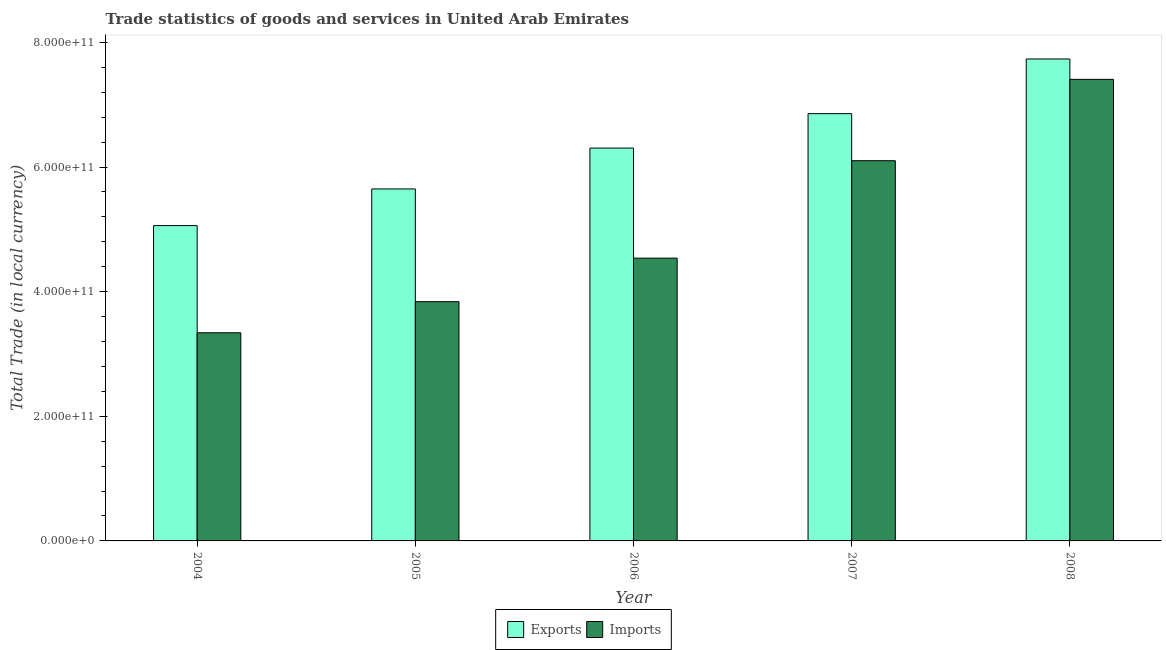How many groups of bars are there?
Your response must be concise. 5. Are the number of bars on each tick of the X-axis equal?
Your answer should be very brief. Yes. How many bars are there on the 3rd tick from the left?
Provide a succinct answer. 2. What is the export of goods and services in 2005?
Ensure brevity in your answer.  5.65e+11. Across all years, what is the maximum imports of goods and services?
Make the answer very short. 7.41e+11. Across all years, what is the minimum imports of goods and services?
Offer a very short reply. 3.34e+11. In which year was the imports of goods and services minimum?
Ensure brevity in your answer.  2004. What is the total export of goods and services in the graph?
Your answer should be very brief. 3.16e+12. What is the difference between the export of goods and services in 2004 and that in 2007?
Offer a very short reply. -1.80e+11. What is the difference between the imports of goods and services in 2008 and the export of goods and services in 2004?
Your response must be concise. 4.07e+11. What is the average export of goods and services per year?
Provide a succinct answer. 6.32e+11. In the year 2008, what is the difference between the imports of goods and services and export of goods and services?
Your response must be concise. 0. What is the ratio of the imports of goods and services in 2004 to that in 2008?
Your answer should be very brief. 0.45. Is the difference between the imports of goods and services in 2004 and 2008 greater than the difference between the export of goods and services in 2004 and 2008?
Your answer should be compact. No. What is the difference between the highest and the second highest imports of goods and services?
Ensure brevity in your answer.  1.31e+11. What is the difference between the highest and the lowest imports of goods and services?
Offer a terse response. 4.07e+11. In how many years, is the imports of goods and services greater than the average imports of goods and services taken over all years?
Keep it short and to the point. 2. Is the sum of the imports of goods and services in 2004 and 2008 greater than the maximum export of goods and services across all years?
Offer a very short reply. Yes. What does the 1st bar from the left in 2008 represents?
Give a very brief answer. Exports. What does the 1st bar from the right in 2008 represents?
Provide a short and direct response. Imports. How many bars are there?
Your answer should be compact. 10. Are all the bars in the graph horizontal?
Offer a terse response. No. How many years are there in the graph?
Give a very brief answer. 5. What is the difference between two consecutive major ticks on the Y-axis?
Make the answer very short. 2.00e+11. Are the values on the major ticks of Y-axis written in scientific E-notation?
Provide a short and direct response. Yes. Does the graph contain grids?
Offer a terse response. No. Where does the legend appear in the graph?
Your answer should be compact. Bottom center. What is the title of the graph?
Provide a succinct answer. Trade statistics of goods and services in United Arab Emirates. Does "Investment" appear as one of the legend labels in the graph?
Ensure brevity in your answer.  No. What is the label or title of the X-axis?
Your answer should be compact. Year. What is the label or title of the Y-axis?
Your answer should be compact. Total Trade (in local currency). What is the Total Trade (in local currency) of Exports in 2004?
Make the answer very short. 5.06e+11. What is the Total Trade (in local currency) in Imports in 2004?
Your answer should be very brief. 3.34e+11. What is the Total Trade (in local currency) of Exports in 2005?
Make the answer very short. 5.65e+11. What is the Total Trade (in local currency) of Imports in 2005?
Provide a short and direct response. 3.84e+11. What is the Total Trade (in local currency) in Exports in 2006?
Offer a terse response. 6.30e+11. What is the Total Trade (in local currency) of Imports in 2006?
Keep it short and to the point. 4.54e+11. What is the Total Trade (in local currency) in Exports in 2007?
Your response must be concise. 6.86e+11. What is the Total Trade (in local currency) of Imports in 2007?
Offer a terse response. 6.10e+11. What is the Total Trade (in local currency) of Exports in 2008?
Your answer should be compact. 7.73e+11. What is the Total Trade (in local currency) in Imports in 2008?
Your response must be concise. 7.41e+11. Across all years, what is the maximum Total Trade (in local currency) in Exports?
Ensure brevity in your answer.  7.73e+11. Across all years, what is the maximum Total Trade (in local currency) of Imports?
Provide a succinct answer. 7.41e+11. Across all years, what is the minimum Total Trade (in local currency) in Exports?
Provide a succinct answer. 5.06e+11. Across all years, what is the minimum Total Trade (in local currency) of Imports?
Provide a short and direct response. 3.34e+11. What is the total Total Trade (in local currency) in Exports in the graph?
Offer a terse response. 3.16e+12. What is the total Total Trade (in local currency) of Imports in the graph?
Keep it short and to the point. 2.52e+12. What is the difference between the Total Trade (in local currency) in Exports in 2004 and that in 2005?
Provide a succinct answer. -5.88e+1. What is the difference between the Total Trade (in local currency) in Imports in 2004 and that in 2005?
Offer a terse response. -4.99e+1. What is the difference between the Total Trade (in local currency) of Exports in 2004 and that in 2006?
Give a very brief answer. -1.24e+11. What is the difference between the Total Trade (in local currency) in Imports in 2004 and that in 2006?
Offer a very short reply. -1.20e+11. What is the difference between the Total Trade (in local currency) of Exports in 2004 and that in 2007?
Provide a short and direct response. -1.80e+11. What is the difference between the Total Trade (in local currency) in Imports in 2004 and that in 2007?
Your answer should be very brief. -2.76e+11. What is the difference between the Total Trade (in local currency) in Exports in 2004 and that in 2008?
Offer a terse response. -2.67e+11. What is the difference between the Total Trade (in local currency) of Imports in 2004 and that in 2008?
Offer a terse response. -4.07e+11. What is the difference between the Total Trade (in local currency) in Exports in 2005 and that in 2006?
Your answer should be very brief. -6.56e+1. What is the difference between the Total Trade (in local currency) in Imports in 2005 and that in 2006?
Ensure brevity in your answer.  -6.99e+1. What is the difference between the Total Trade (in local currency) of Exports in 2005 and that in 2007?
Ensure brevity in your answer.  -1.21e+11. What is the difference between the Total Trade (in local currency) in Imports in 2005 and that in 2007?
Keep it short and to the point. -2.26e+11. What is the difference between the Total Trade (in local currency) in Exports in 2005 and that in 2008?
Keep it short and to the point. -2.09e+11. What is the difference between the Total Trade (in local currency) in Imports in 2005 and that in 2008?
Your answer should be very brief. -3.57e+11. What is the difference between the Total Trade (in local currency) in Exports in 2006 and that in 2007?
Provide a succinct answer. -5.52e+1. What is the difference between the Total Trade (in local currency) of Imports in 2006 and that in 2007?
Your answer should be compact. -1.56e+11. What is the difference between the Total Trade (in local currency) in Exports in 2006 and that in 2008?
Keep it short and to the point. -1.43e+11. What is the difference between the Total Trade (in local currency) in Imports in 2006 and that in 2008?
Provide a succinct answer. -2.87e+11. What is the difference between the Total Trade (in local currency) in Exports in 2007 and that in 2008?
Give a very brief answer. -8.78e+1. What is the difference between the Total Trade (in local currency) in Imports in 2007 and that in 2008?
Make the answer very short. -1.31e+11. What is the difference between the Total Trade (in local currency) in Exports in 2004 and the Total Trade (in local currency) in Imports in 2005?
Make the answer very short. 1.22e+11. What is the difference between the Total Trade (in local currency) in Exports in 2004 and the Total Trade (in local currency) in Imports in 2006?
Give a very brief answer. 5.22e+1. What is the difference between the Total Trade (in local currency) of Exports in 2004 and the Total Trade (in local currency) of Imports in 2007?
Provide a succinct answer. -1.04e+11. What is the difference between the Total Trade (in local currency) of Exports in 2004 and the Total Trade (in local currency) of Imports in 2008?
Make the answer very short. -2.35e+11. What is the difference between the Total Trade (in local currency) in Exports in 2005 and the Total Trade (in local currency) in Imports in 2006?
Offer a terse response. 1.11e+11. What is the difference between the Total Trade (in local currency) of Exports in 2005 and the Total Trade (in local currency) of Imports in 2007?
Your answer should be very brief. -4.53e+1. What is the difference between the Total Trade (in local currency) in Exports in 2005 and the Total Trade (in local currency) in Imports in 2008?
Provide a succinct answer. -1.76e+11. What is the difference between the Total Trade (in local currency) in Exports in 2006 and the Total Trade (in local currency) in Imports in 2007?
Make the answer very short. 2.03e+1. What is the difference between the Total Trade (in local currency) in Exports in 2006 and the Total Trade (in local currency) in Imports in 2008?
Your response must be concise. -1.10e+11. What is the difference between the Total Trade (in local currency) of Exports in 2007 and the Total Trade (in local currency) of Imports in 2008?
Provide a short and direct response. -5.51e+1. What is the average Total Trade (in local currency) in Exports per year?
Offer a terse response. 6.32e+11. What is the average Total Trade (in local currency) of Imports per year?
Ensure brevity in your answer.  5.05e+11. In the year 2004, what is the difference between the Total Trade (in local currency) in Exports and Total Trade (in local currency) in Imports?
Make the answer very short. 1.72e+11. In the year 2005, what is the difference between the Total Trade (in local currency) in Exports and Total Trade (in local currency) in Imports?
Make the answer very short. 1.81e+11. In the year 2006, what is the difference between the Total Trade (in local currency) of Exports and Total Trade (in local currency) of Imports?
Make the answer very short. 1.77e+11. In the year 2007, what is the difference between the Total Trade (in local currency) in Exports and Total Trade (in local currency) in Imports?
Your answer should be very brief. 7.55e+1. In the year 2008, what is the difference between the Total Trade (in local currency) of Exports and Total Trade (in local currency) of Imports?
Give a very brief answer. 3.27e+1. What is the ratio of the Total Trade (in local currency) of Exports in 2004 to that in 2005?
Provide a succinct answer. 0.9. What is the ratio of the Total Trade (in local currency) of Imports in 2004 to that in 2005?
Ensure brevity in your answer.  0.87. What is the ratio of the Total Trade (in local currency) of Exports in 2004 to that in 2006?
Offer a terse response. 0.8. What is the ratio of the Total Trade (in local currency) in Imports in 2004 to that in 2006?
Your answer should be compact. 0.74. What is the ratio of the Total Trade (in local currency) in Exports in 2004 to that in 2007?
Ensure brevity in your answer.  0.74. What is the ratio of the Total Trade (in local currency) of Imports in 2004 to that in 2007?
Provide a succinct answer. 0.55. What is the ratio of the Total Trade (in local currency) in Exports in 2004 to that in 2008?
Your answer should be compact. 0.65. What is the ratio of the Total Trade (in local currency) in Imports in 2004 to that in 2008?
Provide a succinct answer. 0.45. What is the ratio of the Total Trade (in local currency) in Exports in 2005 to that in 2006?
Keep it short and to the point. 0.9. What is the ratio of the Total Trade (in local currency) of Imports in 2005 to that in 2006?
Give a very brief answer. 0.85. What is the ratio of the Total Trade (in local currency) of Exports in 2005 to that in 2007?
Make the answer very short. 0.82. What is the ratio of the Total Trade (in local currency) in Imports in 2005 to that in 2007?
Your response must be concise. 0.63. What is the ratio of the Total Trade (in local currency) of Exports in 2005 to that in 2008?
Keep it short and to the point. 0.73. What is the ratio of the Total Trade (in local currency) in Imports in 2005 to that in 2008?
Give a very brief answer. 0.52. What is the ratio of the Total Trade (in local currency) in Exports in 2006 to that in 2007?
Offer a very short reply. 0.92. What is the ratio of the Total Trade (in local currency) in Imports in 2006 to that in 2007?
Your answer should be very brief. 0.74. What is the ratio of the Total Trade (in local currency) in Exports in 2006 to that in 2008?
Your answer should be compact. 0.82. What is the ratio of the Total Trade (in local currency) of Imports in 2006 to that in 2008?
Provide a short and direct response. 0.61. What is the ratio of the Total Trade (in local currency) of Exports in 2007 to that in 2008?
Keep it short and to the point. 0.89. What is the ratio of the Total Trade (in local currency) of Imports in 2007 to that in 2008?
Make the answer very short. 0.82. What is the difference between the highest and the second highest Total Trade (in local currency) in Exports?
Give a very brief answer. 8.78e+1. What is the difference between the highest and the second highest Total Trade (in local currency) of Imports?
Give a very brief answer. 1.31e+11. What is the difference between the highest and the lowest Total Trade (in local currency) in Exports?
Your response must be concise. 2.67e+11. What is the difference between the highest and the lowest Total Trade (in local currency) in Imports?
Keep it short and to the point. 4.07e+11. 